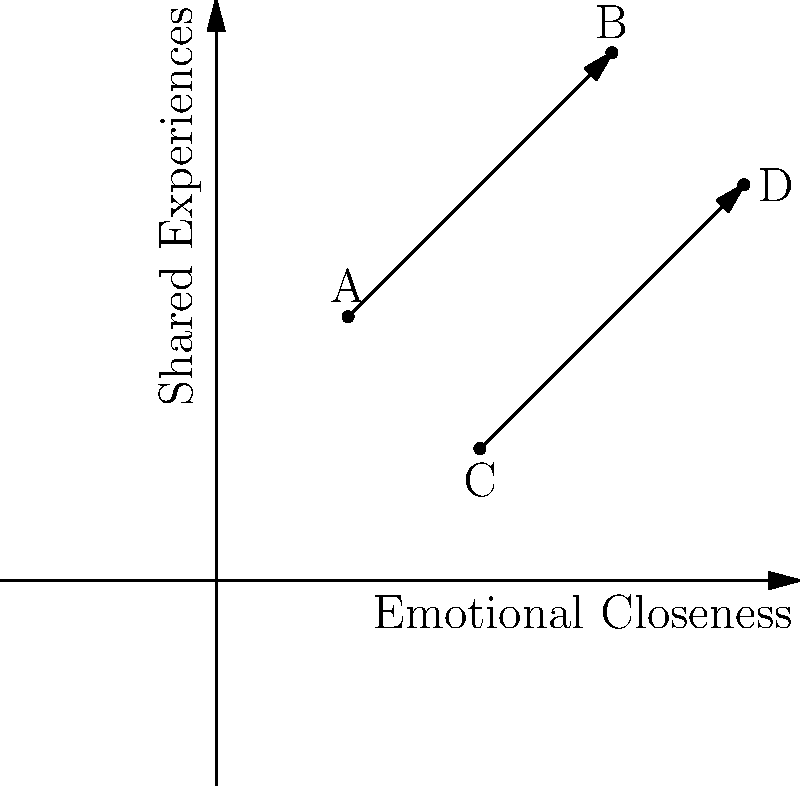In your novel, you've plotted four characters (A, B, C, and D) on a 2D grid based on their emotional closeness (x-axis) and shared experiences (y-axis). Given the relationships shown in the graph, which character pair has the strongest overall connection, and what does this imply for your story's development? To determine the character pair with the strongest overall connection, we need to analyze their positions on the grid:

1. Identify the character pairs:
   - A and B
   - C and D

2. Calculate the distance between each pair:
   - For A and B: $\sqrt{(3-1)^2 + (4-2)^2} = \sqrt{8} \approx 2.83$
   - For C and D: $\sqrt{(4-2)^2 + (3-1)^2} = \sqrt{8} \approx 2.83$

3. Compare the positions:
   - A and B are higher on both axes, indicating stronger emotional closeness and more shared experiences.
   - C and D are lower on both axes, suggesting weaker emotional ties and fewer shared experiences.

4. Interpret the results:
   - Although the distances are the same, A and B have a stronger overall connection due to their higher positions on both axes.

5. Implications for story development:
   - The strong connection between A and B could be a central focus of the plot.
   - Their relationship might drive the narrative or create conflict with other characters.
   - The weaker connection between C and D could provide opportunities for character growth or subplots.
Answer: A and B; potential for central plot focus and character conflicts 